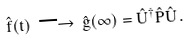Convert formula to latex. <formula><loc_0><loc_0><loc_500><loc_500>\hat { f } ( t ) \, \longrightarrow \, \hat { g } ( \infty ) = \hat { U } ^ { \dagger } \hat { P } \hat { U } \, .</formula> 